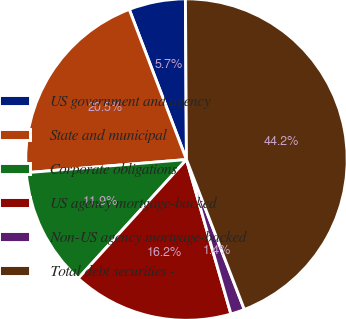Convert chart to OTSL. <chart><loc_0><loc_0><loc_500><loc_500><pie_chart><fcel>US government and agency<fcel>State and municipal<fcel>Corporate obligations<fcel>US agency mortgage-backed<fcel>Non-US agency mortgage-backed<fcel>Total debt securities -<nl><fcel>5.69%<fcel>20.51%<fcel>11.94%<fcel>16.22%<fcel>1.4%<fcel>44.24%<nl></chart> 